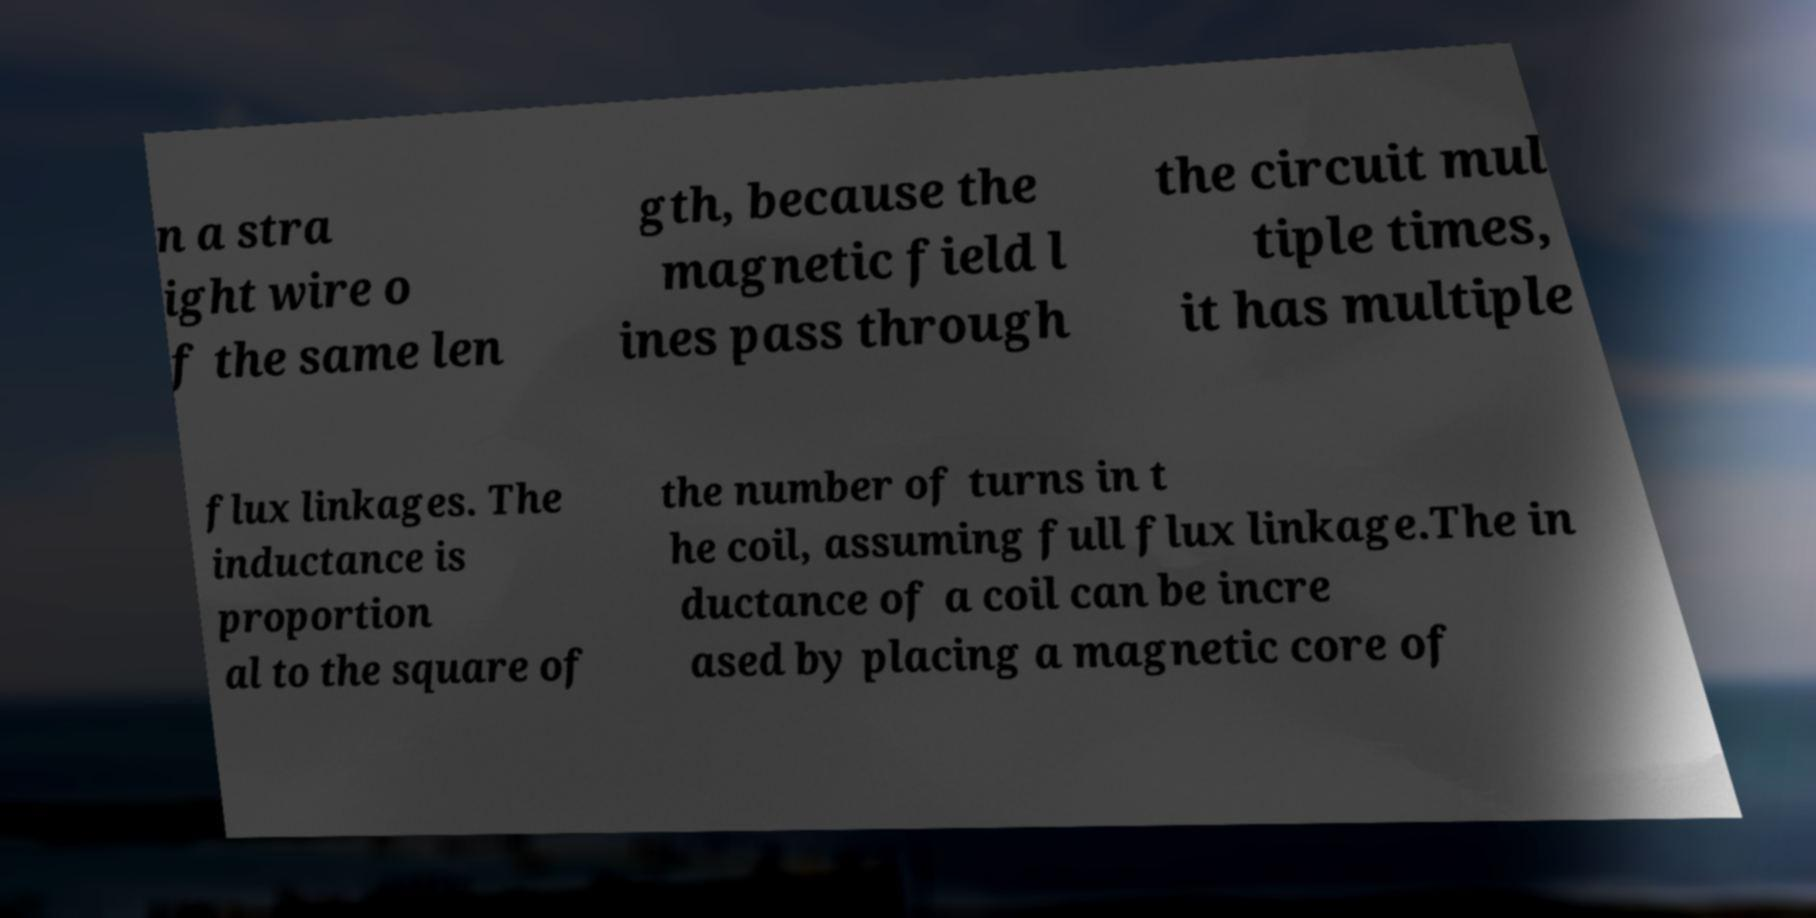There's text embedded in this image that I need extracted. Can you transcribe it verbatim? n a stra ight wire o f the same len gth, because the magnetic field l ines pass through the circuit mul tiple times, it has multiple flux linkages. The inductance is proportion al to the square of the number of turns in t he coil, assuming full flux linkage.The in ductance of a coil can be incre ased by placing a magnetic core of 